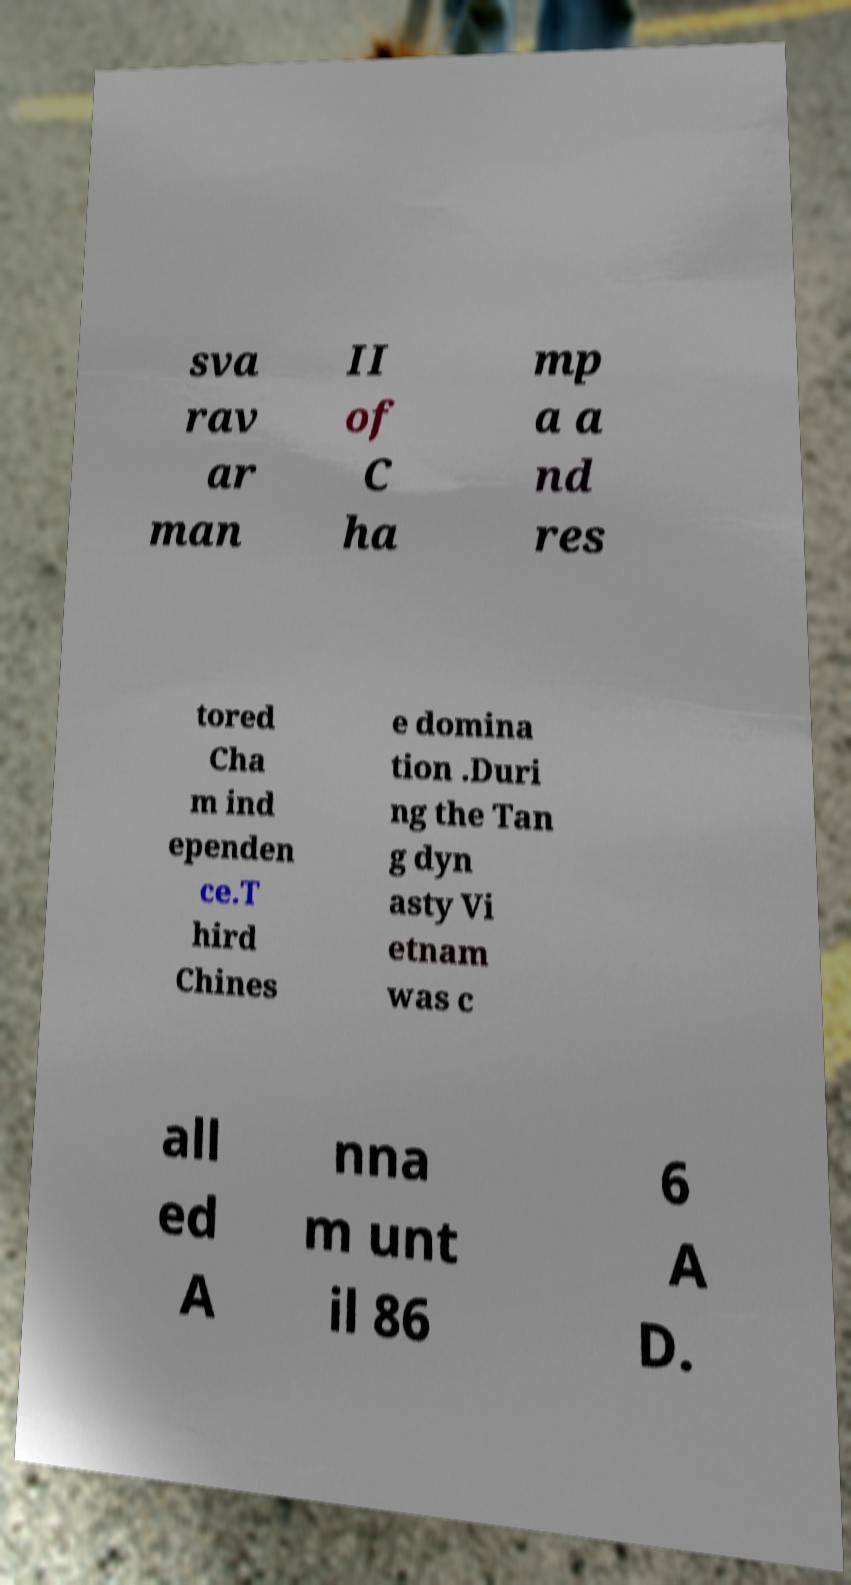Please identify and transcribe the text found in this image. sva rav ar man II of C ha mp a a nd res tored Cha m ind ependen ce.T hird Chines e domina tion .Duri ng the Tan g dyn asty Vi etnam was c all ed A nna m unt il 86 6 A D. 